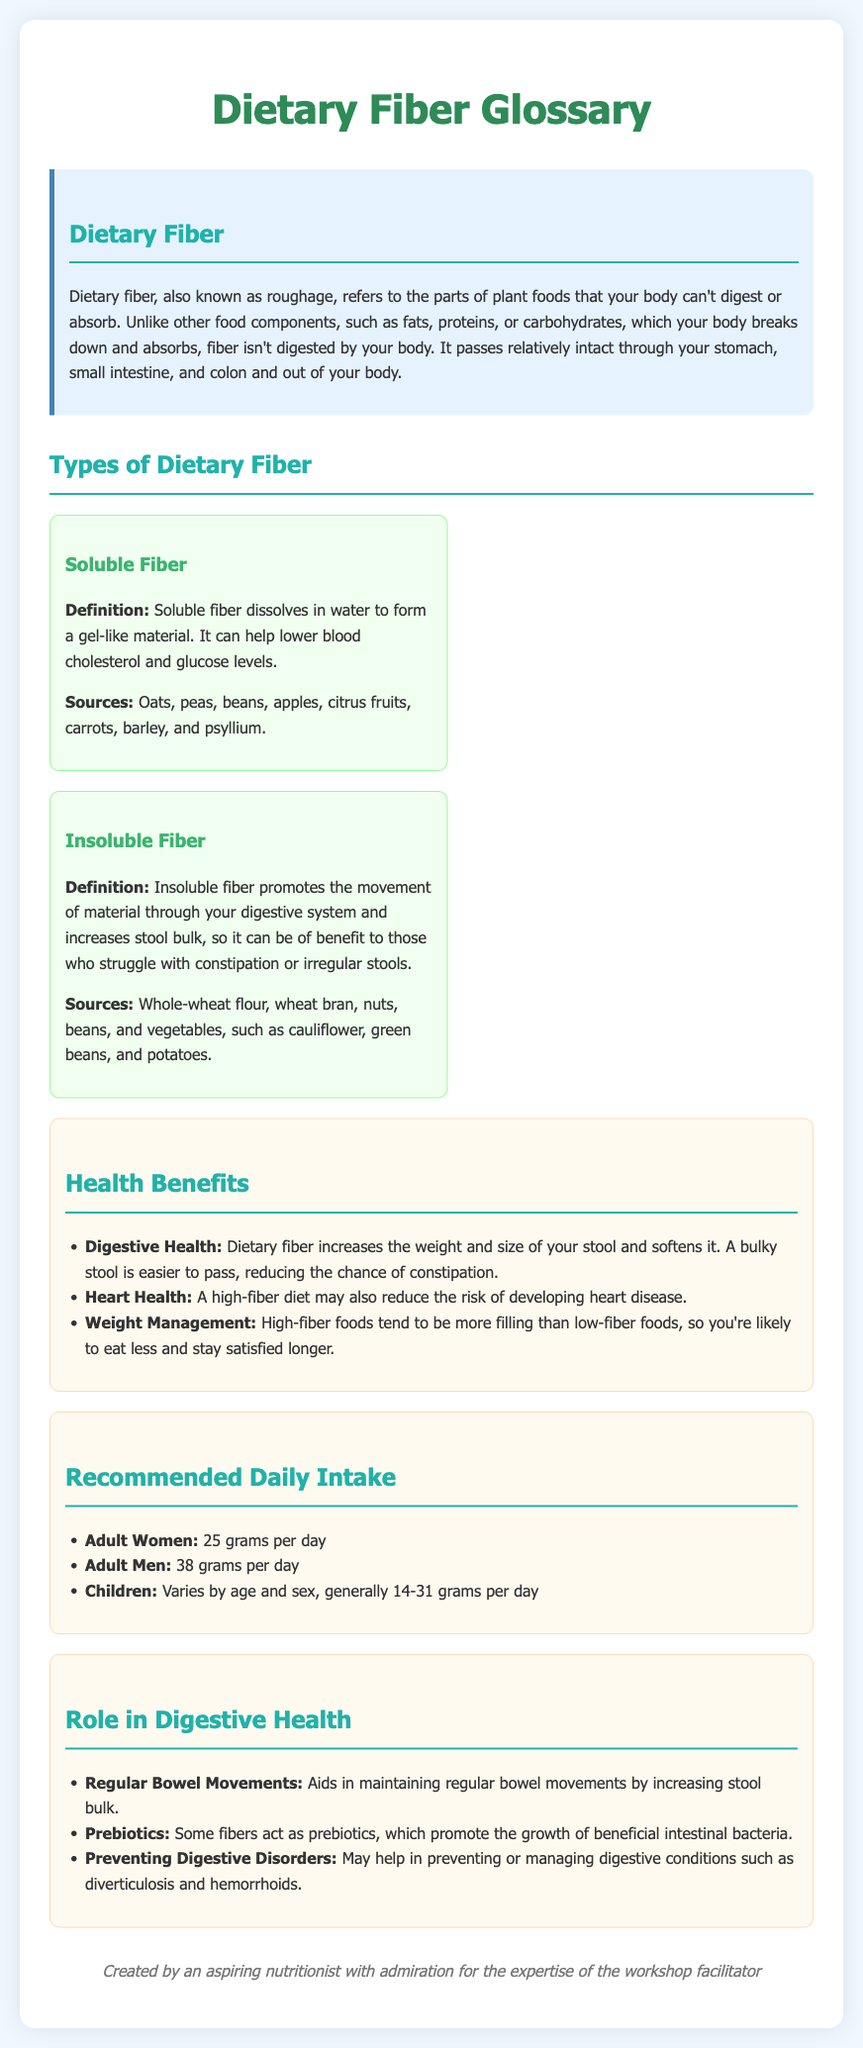What is dietary fiber? Dietary fiber is defined in the document as the parts of plant foods that your body can't digest or absorb.
Answer: Parts of plant foods What are the sources of soluble fiber? The document lists foods that are sources of soluble fiber, such as oats, peas, and apples.
Answer: Oats, peas, beans, apples, citrus fruits, carrots, barley, psyllium What is the recommended daily intake for adult women? The document specifies the daily fiber intake recommendation for adult women as given in a list.
Answer: 25 grams What type of fiber aids in preventing constipation? A specific type of fiber is mentioned in relation to promoting digestive movement.
Answer: Insoluble fiber How many grams of fiber should adult men consume daily? The document provides a numerical recommendation for adult men regarding fiber intake.
Answer: 38 grams What health benefit is associated with a high-fiber diet related to heart disease? The document states that a high-fiber diet may reduce the risk of developing a specific health condition.
Answer: Heart disease Which type of fiber dissolves in water? The document distinguishes between the two types of dietary fiber and specifies one that dissolves in water.
Answer: Soluble fiber What is one role of fiber in digestive health? The document mentions several roles of fiber, focusing on its impact on bowel movements.
Answer: Regular bowel movements What is a food source of insoluble fiber? The document provides examples of foods rich in insoluble fiber.
Answer: Whole-wheat flour, wheat bran, nuts, beans, vegetables 